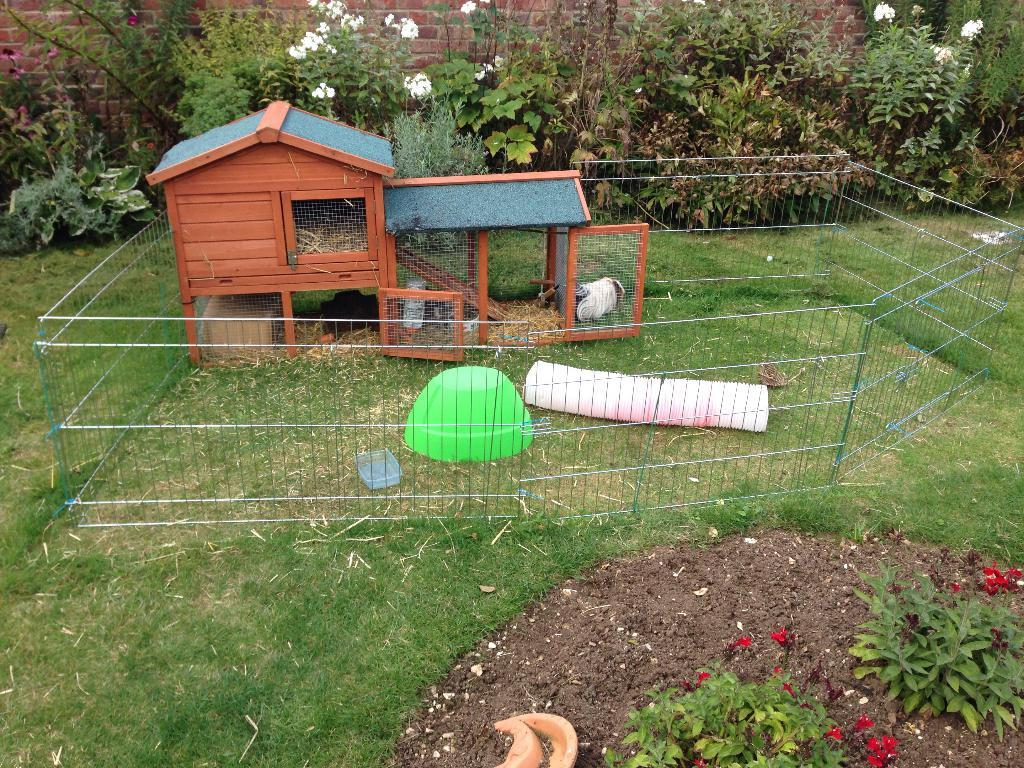What type of structure can be seen in the image? There is a shed in the image. What can be seen on the ground in the image? The ground is visible in the image, with some grass and a few objects. What type of barrier is present in the image? There is a fence in the image. What type of vegetation is present in the image? There are plants and flowers in the image. What type of wall is visible in the image? There is a wall in the image. What type of nerve can be seen in the image? There is no nerve present in the image. What type of pot is visible in the image? There is no pot visible in the image. 